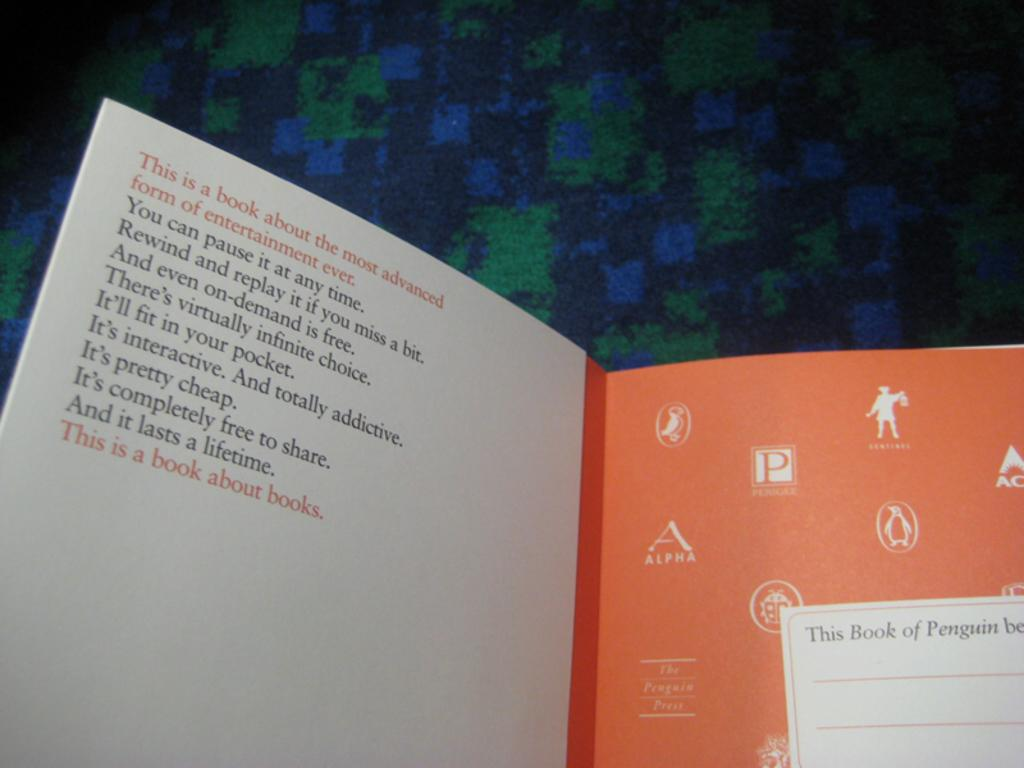Provide a one-sentence caption for the provided image. The book says it's a book about books and the inscription on the inside cover lists many of the benefits of reading. 